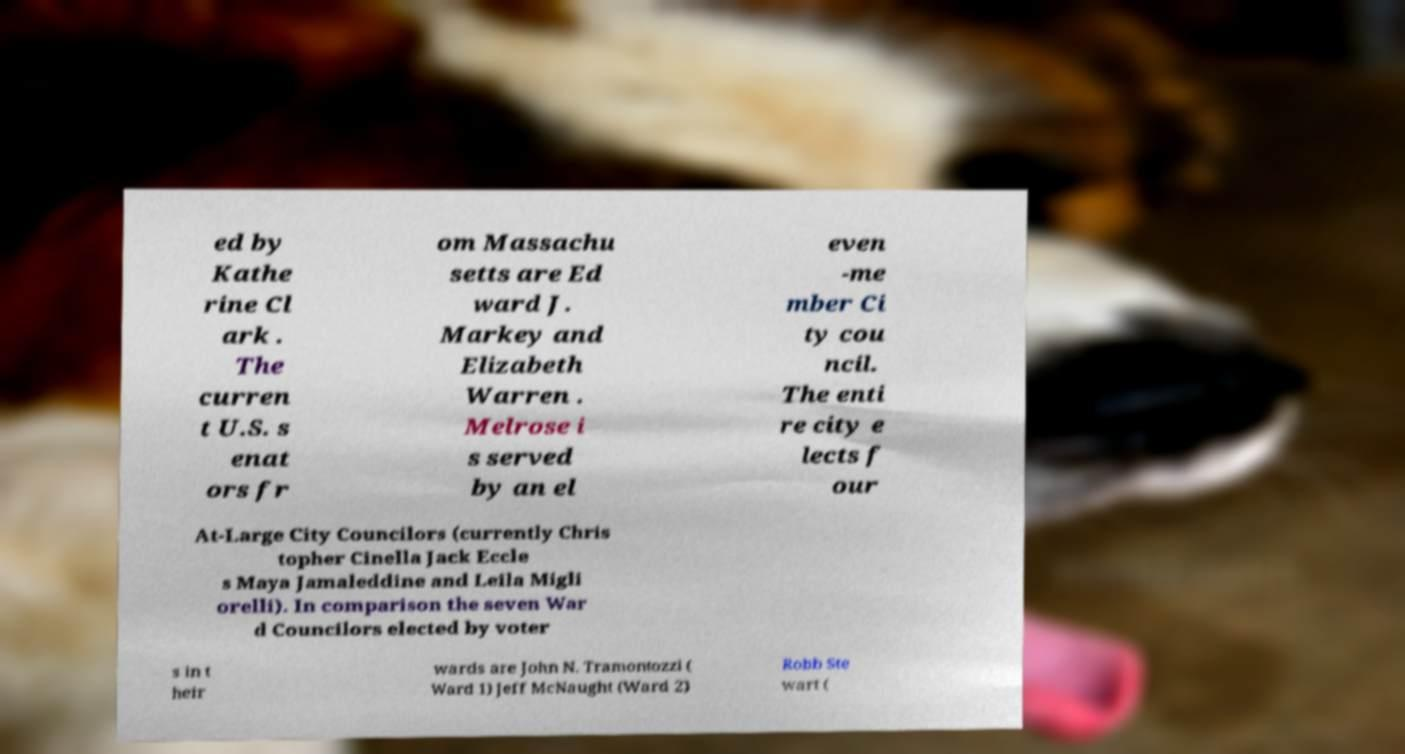Could you assist in decoding the text presented in this image and type it out clearly? ed by Kathe rine Cl ark . The curren t U.S. s enat ors fr om Massachu setts are Ed ward J. Markey and Elizabeth Warren . Melrose i s served by an el even -me mber Ci ty cou ncil. The enti re city e lects f our At-Large City Councilors (currently Chris topher Cinella Jack Eccle s Maya Jamaleddine and Leila Migli orelli). In comparison the seven War d Councilors elected by voter s in t heir wards are John N. Tramontozzi ( Ward 1) Jeff McNaught (Ward 2) Robb Ste wart ( 